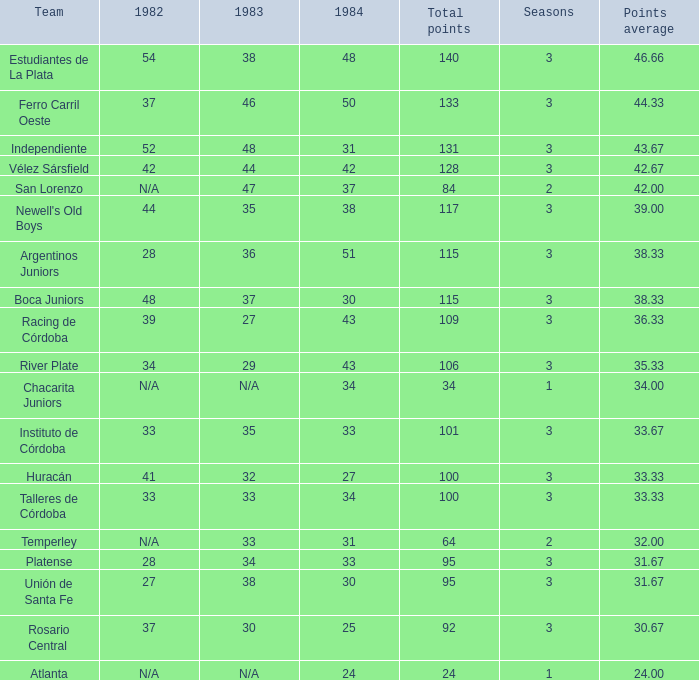What is the number of seasons for the team with a total fewer than 24? None. 